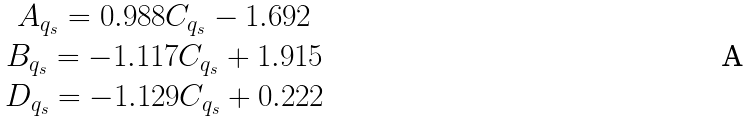<formula> <loc_0><loc_0><loc_500><loc_500>\begin{array} { c l l l c } A _ { q _ { s } } = 0 . 9 8 8 C _ { q _ { s } } - 1 . 6 9 2 \\ B _ { q _ { s } } = - 1 . 1 1 7 C _ { q _ { s } } + 1 . 9 1 5 \\ D _ { q _ { s } } = - 1 . 1 2 9 C _ { q _ { s } } + 0 . 2 2 2 \end{array}</formula> 